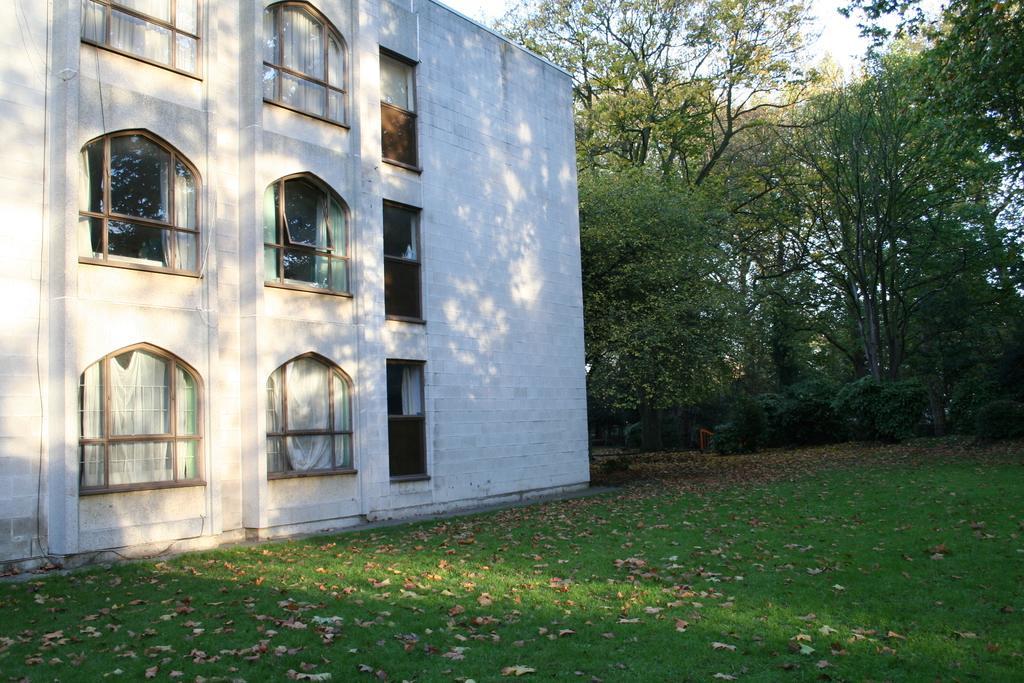Please provide a concise description of this image. We can see leaves on the grass and we can see building,wall and windows. In the background we can see trees and sky. 